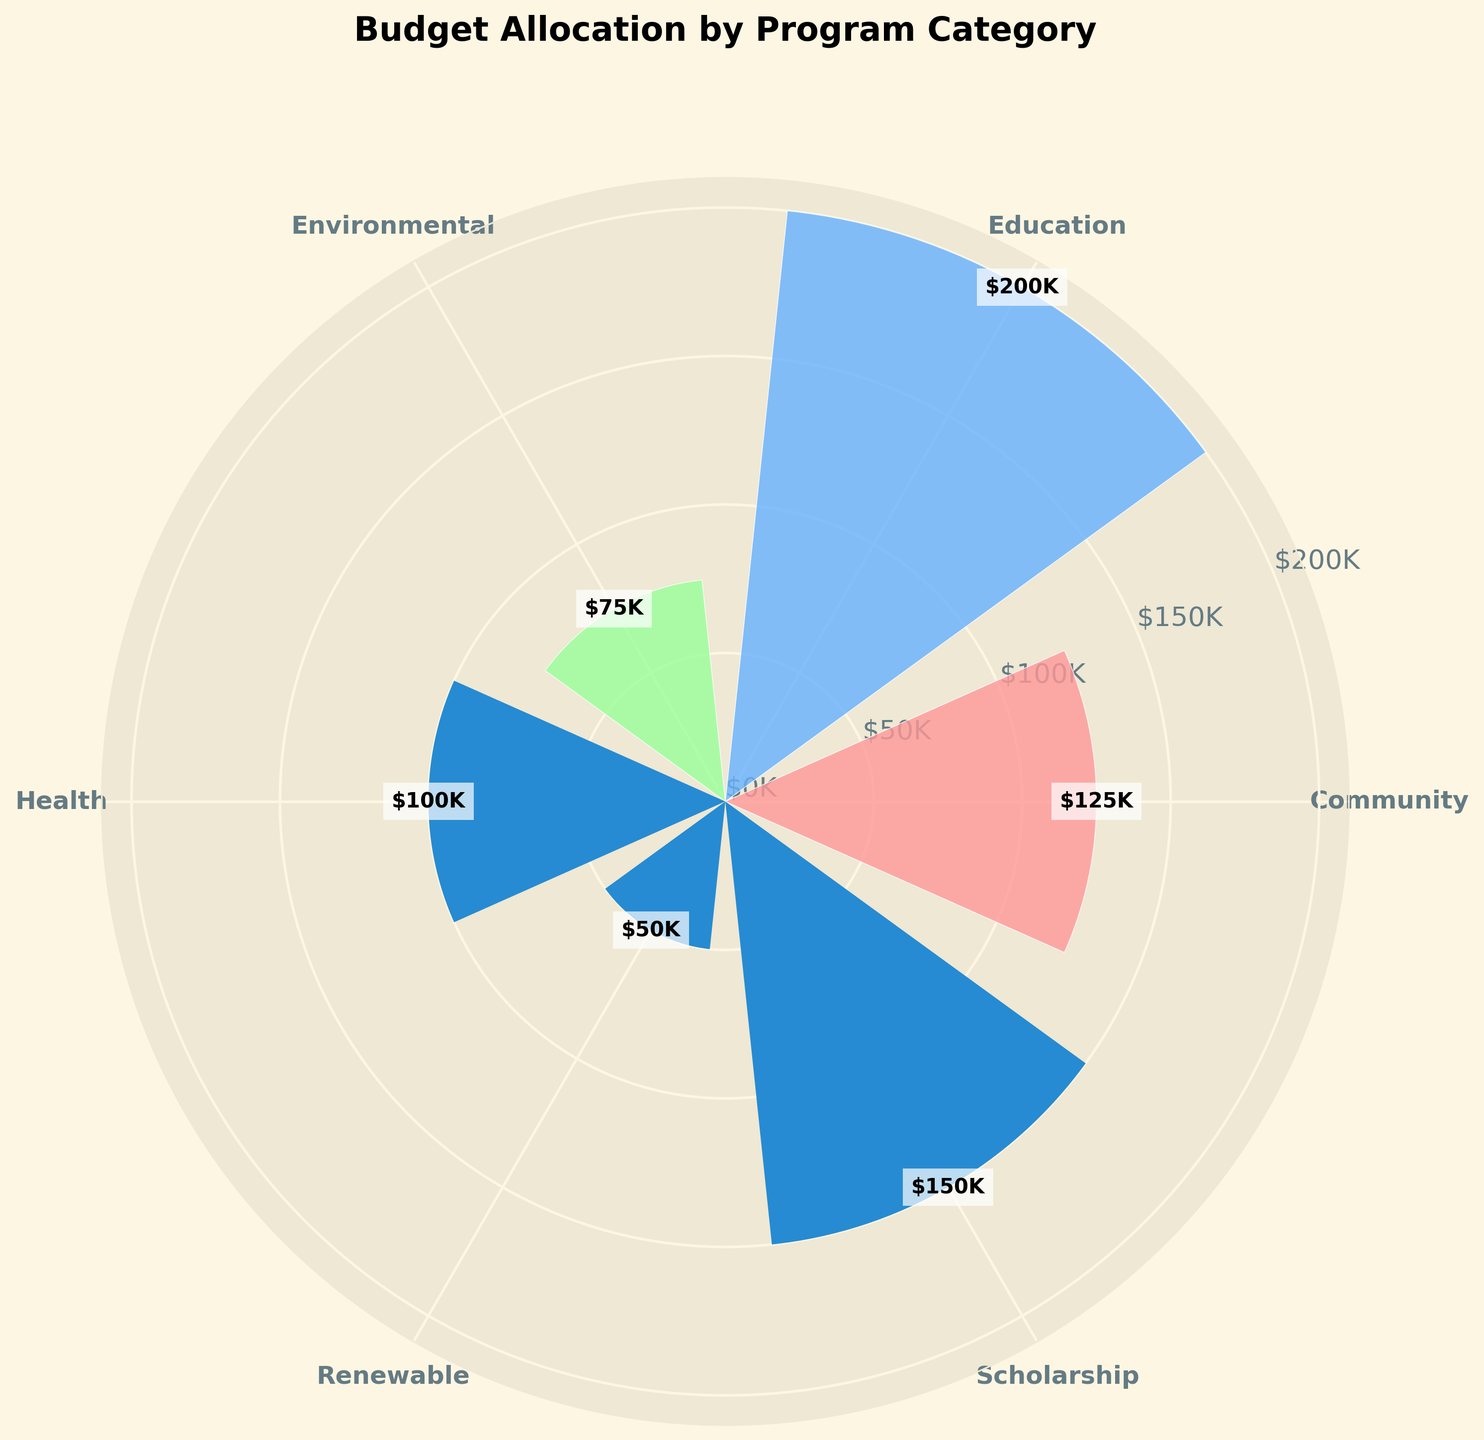What is the title of the chart? The title is located above the chart, usually at the top center of the figure.
Answer: Budget Allocation by Program Category How many program categories are shown on the chart? Count the number of distinct labels around the circle representing different program categories.
Answer: 3 What amount is allocated to the Education category? Look for the 'Education' label on the chart and read the corresponding value in the bar.
Answer: $350K Which program category has the smallest budget allocation? Compare the heights of the bars representing each program category to find the smallest one.
Answer: Environment What is the total budget allocated across all program categories? Sum the budget amounts of Education ($350K), Health ($225K), and Environment ($125K) based on the chart.
Answer: $700K How does the budget for Education compare to the budget for Health? Identify the heights of the bars for Education ($350K) and Health ($225K) and compare their values.
Answer: Education has $125K more than Health What proportion of the budget is allocated to the Environment category? Calculate the ratio of the Environment budget ($125K) to the total budget ($700K),  then convert it to a percentage.
Answer: ~17.9% Which category's budget is approximately twice the size of the Environment category? Determine the budget of the Environment category ($125K) and find a category whose budget is approximately twice ($250K).
Answer: Education What is the average budget allocation per category? Sum the budgets of all categories ($700K) and divide by the number of categories (3).
Answer: ~$233K Which category has the most diverse set of programs in terms of budget allocation? Evaluate which category has different heights and values in its respective bars.
Answer: Education 